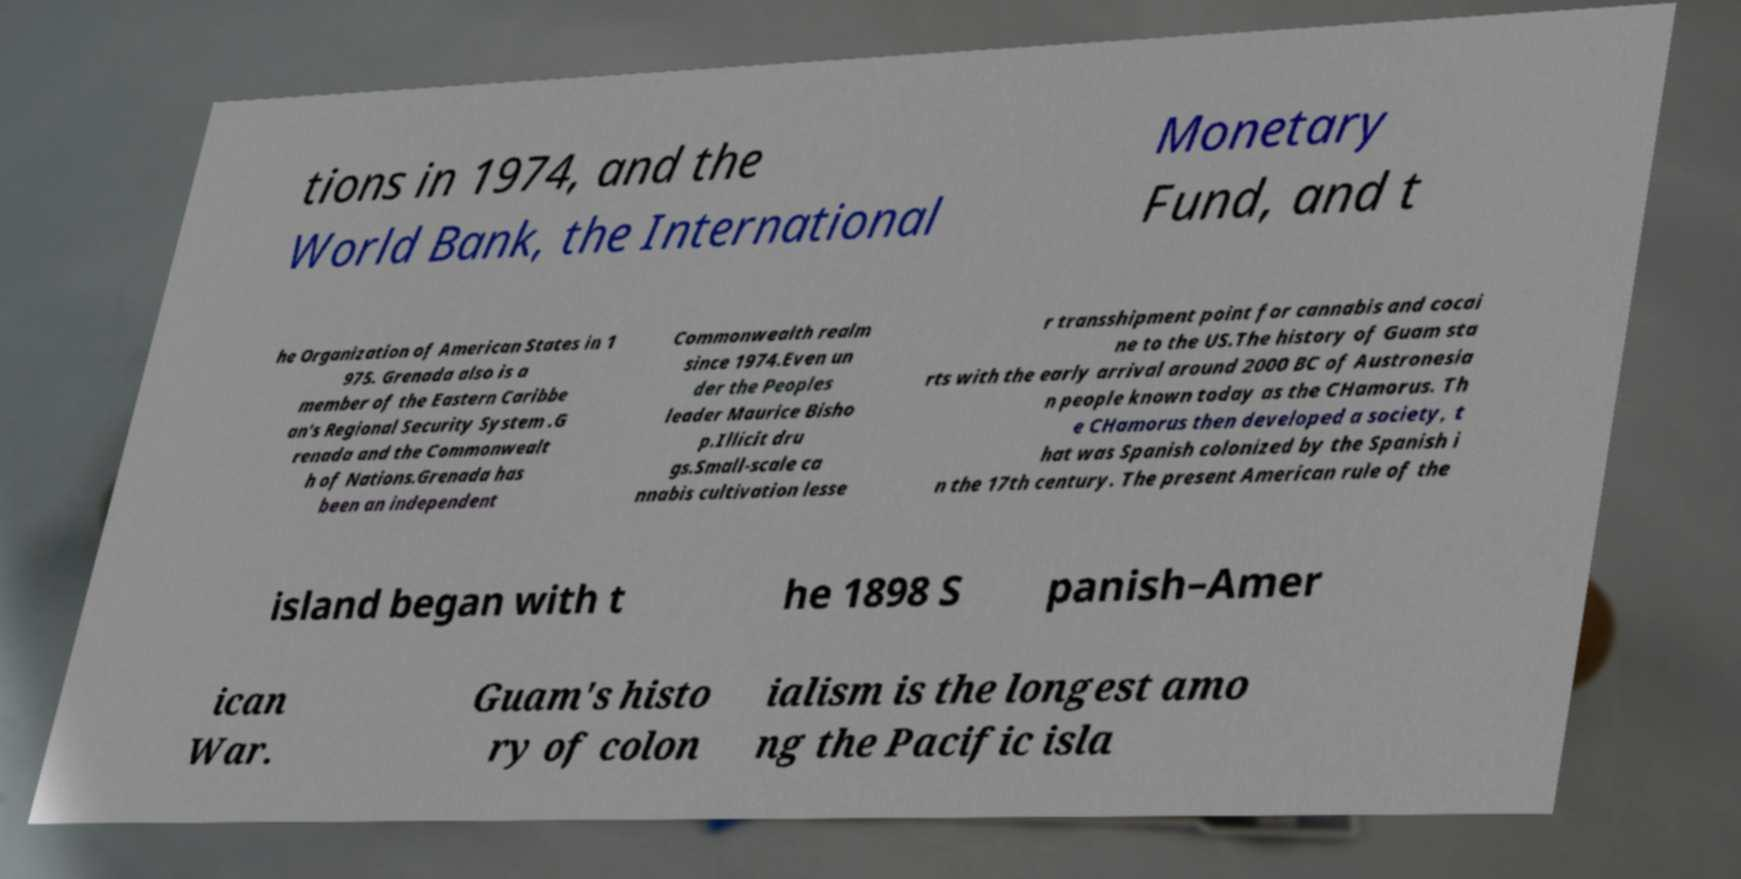Could you extract and type out the text from this image? tions in 1974, and the World Bank, the International Monetary Fund, and t he Organization of American States in 1 975. Grenada also is a member of the Eastern Caribbe an's Regional Security System .G renada and the Commonwealt h of Nations.Grenada has been an independent Commonwealth realm since 1974.Even un der the Peoples leader Maurice Bisho p.Illicit dru gs.Small-scale ca nnabis cultivation lesse r transshipment point for cannabis and cocai ne to the US.The history of Guam sta rts with the early arrival around 2000 BC of Austronesia n people known today as the CHamorus. Th e CHamorus then developed a society, t hat was Spanish colonized by the Spanish i n the 17th century. The present American rule of the island began with t he 1898 S panish–Amer ican War. Guam's histo ry of colon ialism is the longest amo ng the Pacific isla 